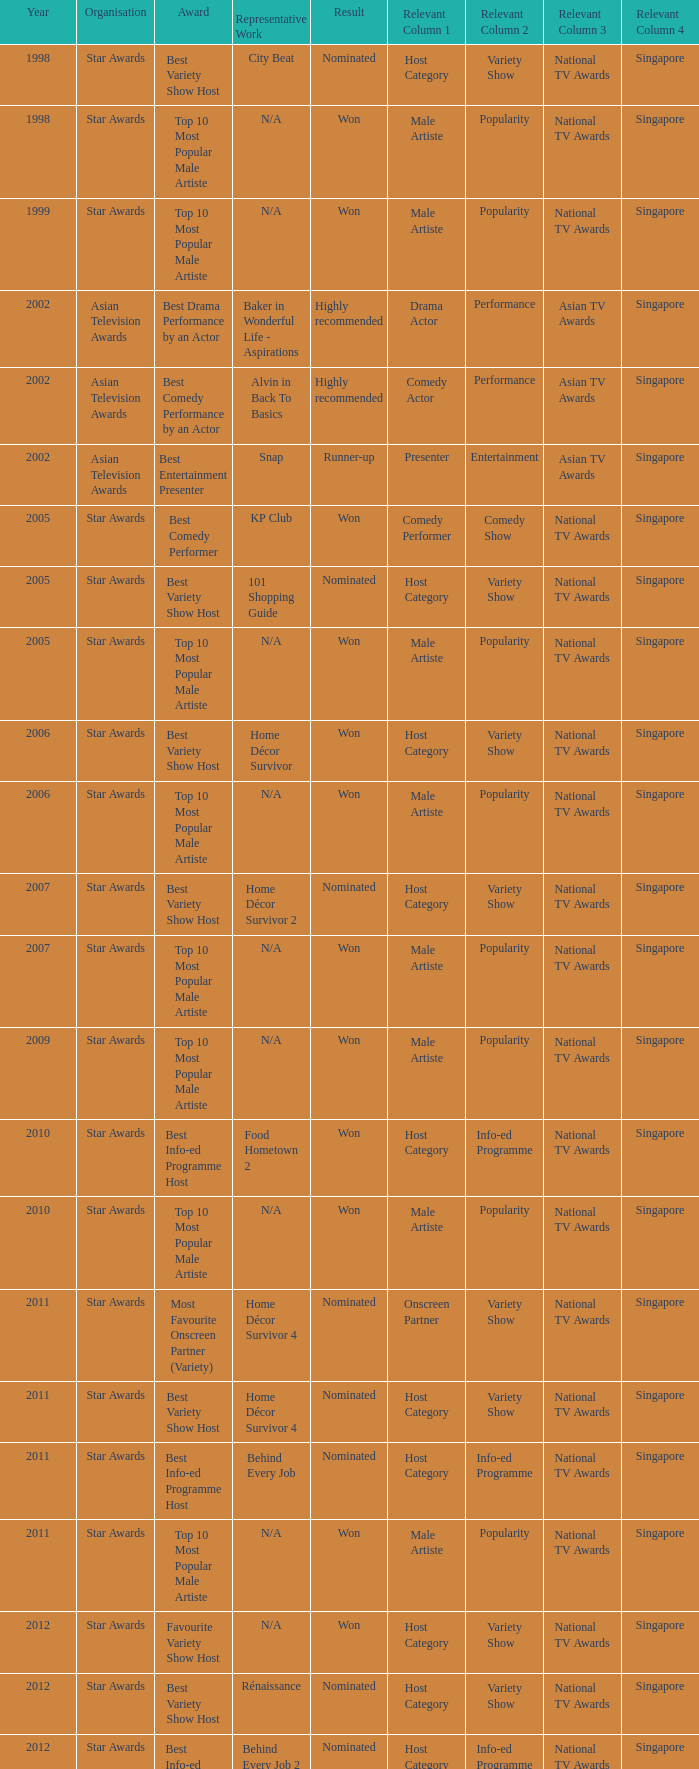What is the award for the Star Awards earlier than 2005 and the result is won? Top 10 Most Popular Male Artiste, Top 10 Most Popular Male Artiste. 